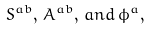Convert formula to latex. <formula><loc_0><loc_0><loc_500><loc_500>S ^ { a b } , \, A ^ { a b } , \, a n d \, \phi ^ { a } ,</formula> 